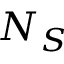<formula> <loc_0><loc_0><loc_500><loc_500>N _ { S }</formula> 